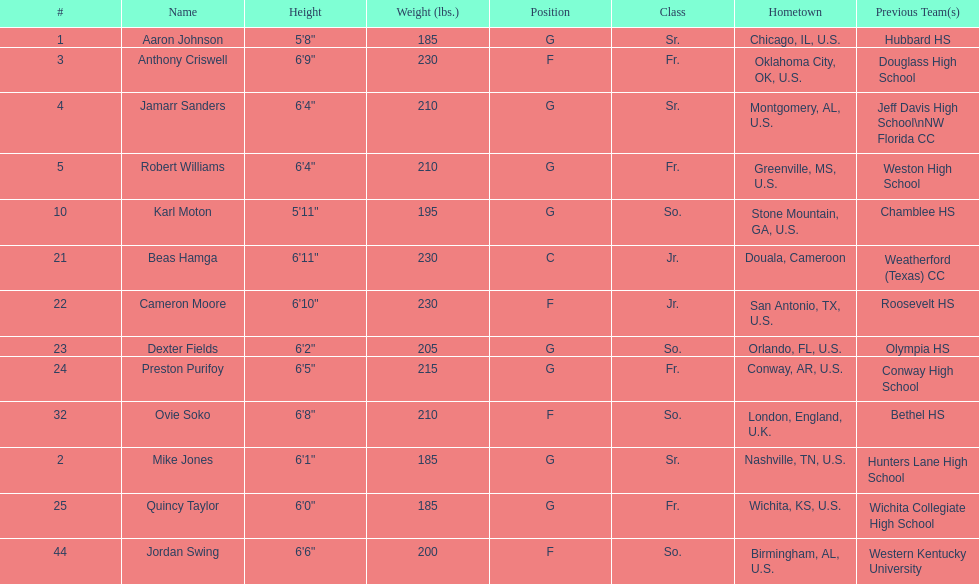What is the number of players originating from alabama? 2. 